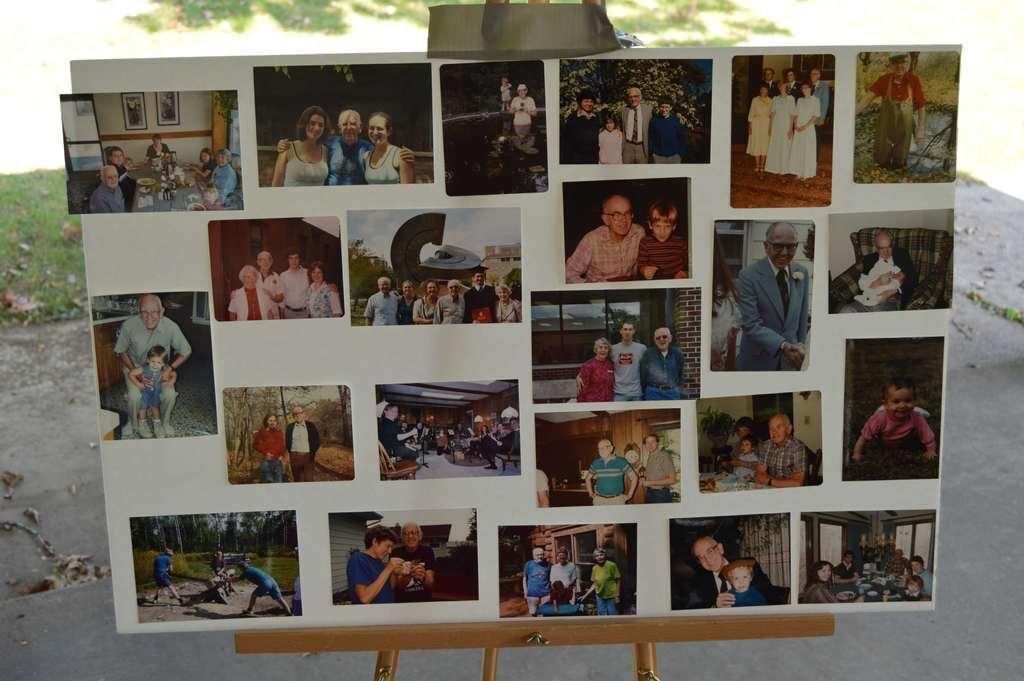What is the main subject of the image? The main subject of the image is photographs attached to a painting board. Where are the photographs located in the image? The photographs are in the middle of the image. What can be seen at the top of the image? There is a tree at the top of the image. What type of drug is visible on the painting board in the image? There is no drug present in the image; it features photographs attached to a painting board. How many seats are visible in the image? There are no seats visible in the image. 